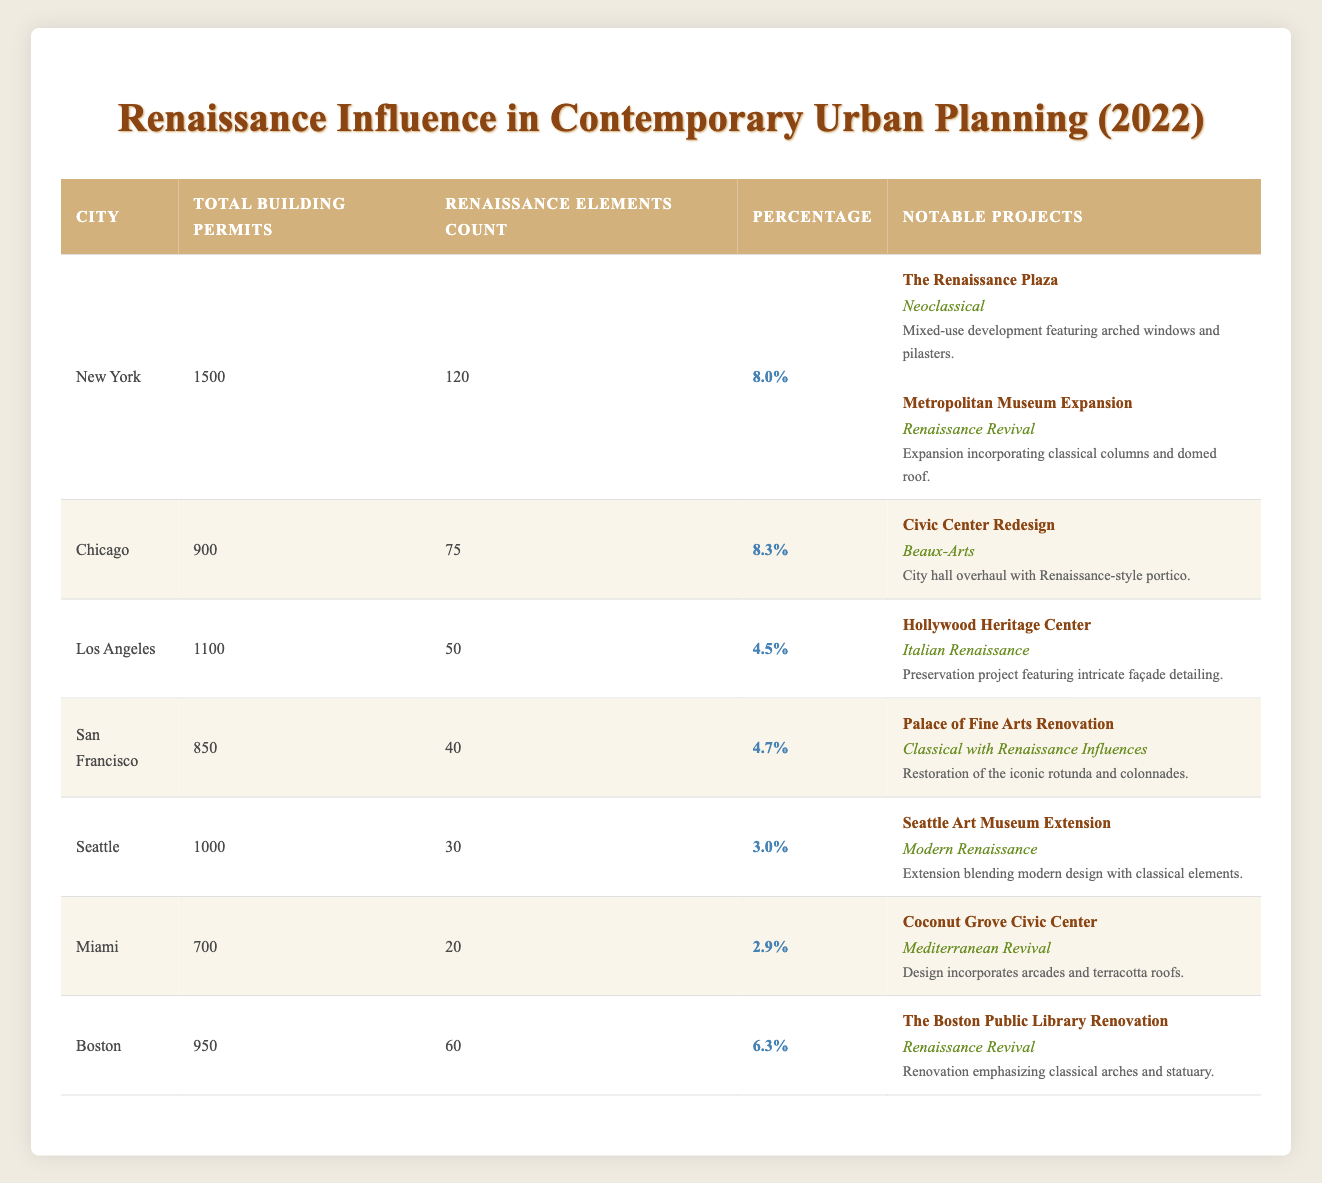What city had the highest number of Renaissance Elements Count in 2022? By looking at the table, New York has the highest count with 120 Renaissance elements, compared to other cities. The rest of the cities have lower counts such as Chicago with 75, Los Angeles with 50, and so on.
Answer: New York What is the total number of building permits for Chicago in 2022? The table shows that Chicago had a total of 900 building permits issued in the year 2022.
Answer: 900 Which city had the lowest percentage of Renaissance-inspired elements in their building permits? By reviewing the percentage column, Miami has the lowest at 2.9%. All other cities have higher percentages of Renaissance-inspired elements in their building permits.
Answer: Miami How many total Renaissance Elements Count were issued across all cities in 2022? To find the total, sum the Renaissance elements from each city: 120 (New York) + 75 (Chicago) + 50 (Los Angeles) + 40 (San Francisco) + 30 (Seattle) + 20 (Miami) + 60 (Boston) = 395.
Answer: 395 Did any city not have notable projects listed in their building permits? No, all cities listed have at least one notable project documented in relation to their Renaissance Elements Count.
Answer: No What is the average percentage of Renaissance Elements across the cities mentioned in the table? First, sum the percentages: 8.0 + 8.3 + 4.5 + 4.7 + 3.0 + 2.9 + 6.3 = 37.7. There are 7 cities, so the average percentage is 37.7/7 = 5.39.
Answer: 5.39 Which city's most notable project is the "Palace of Fine Arts Renovation"? The table indicates that "Palace of Fine Arts Renovation" is a notable project for San Francisco.
Answer: San Francisco How many more building permits did New York issue compared to Seattle? The difference is calculated by subtracting Seattle's permits (1000) from New York's (1500): 1500 - 1000 = 500.
Answer: 500 What proportion of the total building permits in Los Angeles were Renaissance-inspired elements? The proportion can be determined using the formula: (Renaissance Elements Count / Total Building Permits) * 100 = (50/1100) * 100 = 4.5%.
Answer: 4.5% 